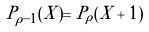<formula> <loc_0><loc_0><loc_500><loc_500>P _ { \rho - 1 } ( X ) = P _ { \rho } ( X + 1 )</formula> 